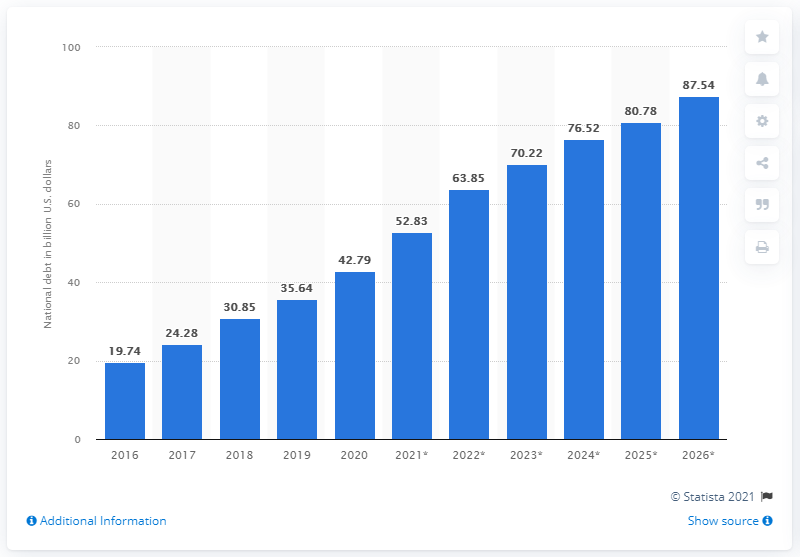Give some essential details in this illustration. In 2020, the national debt of Ethiopia was approximately 42.79 billion dollars. 